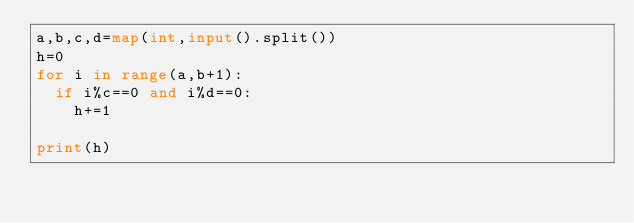Convert code to text. <code><loc_0><loc_0><loc_500><loc_500><_Python_>a,b,c,d=map(int,input().split())
h=0
for i in range(a,b+1):
  if i%c==0 and i%d==0:
    h+=1
    
print(h)</code> 